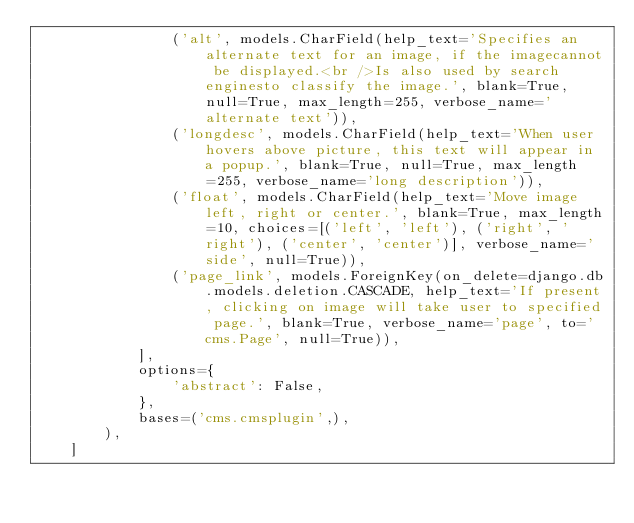Convert code to text. <code><loc_0><loc_0><loc_500><loc_500><_Python_>                ('alt', models.CharField(help_text='Specifies an alternate text for an image, if the imagecannot be displayed.<br />Is also used by search enginesto classify the image.', blank=True, null=True, max_length=255, verbose_name='alternate text')),
                ('longdesc', models.CharField(help_text='When user hovers above picture, this text will appear in a popup.', blank=True, null=True, max_length=255, verbose_name='long description')),
                ('float', models.CharField(help_text='Move image left, right or center.', blank=True, max_length=10, choices=[('left', 'left'), ('right', 'right'), ('center', 'center')], verbose_name='side', null=True)),
                ('page_link', models.ForeignKey(on_delete=django.db.models.deletion.CASCADE, help_text='If present, clicking on image will take user to specified page.', blank=True, verbose_name='page', to='cms.Page', null=True)),
            ],
            options={
                'abstract': False,
            },
            bases=('cms.cmsplugin',),
        ),
    ]
</code> 